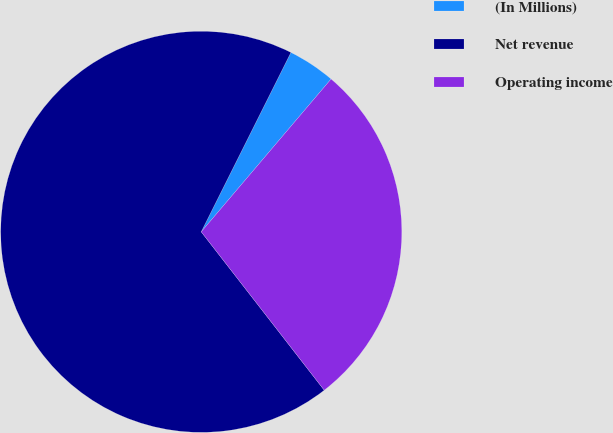<chart> <loc_0><loc_0><loc_500><loc_500><pie_chart><fcel>(In Millions)<fcel>Net revenue<fcel>Operating income<nl><fcel>3.83%<fcel>67.89%<fcel>28.28%<nl></chart> 